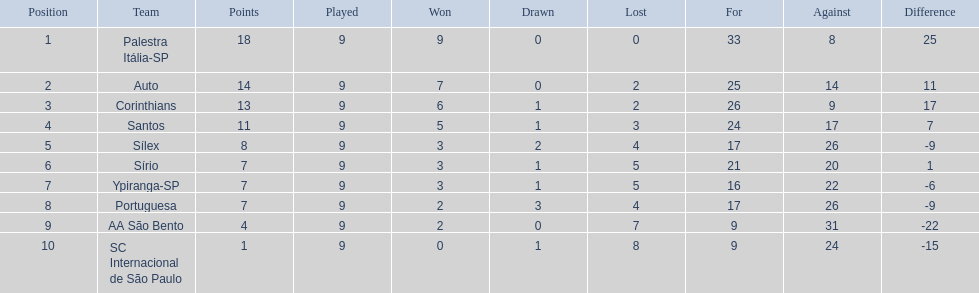Which teams participated in 1926? Palestra Itália-SP, Auto, Corinthians, Santos, Sílex, Sírio, Ypiranga-SP, Portuguesa, AA São Bento, SC Internacional de São Paulo. Were there any teams that didn't lose a single game? Palestra Itália-SP. 